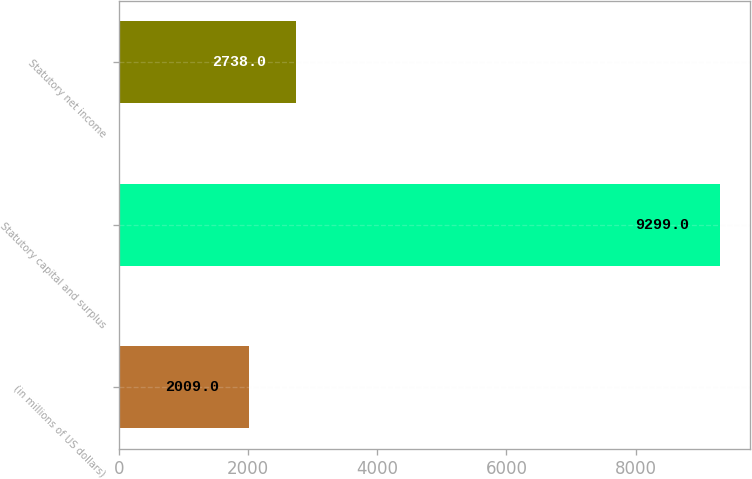<chart> <loc_0><loc_0><loc_500><loc_500><bar_chart><fcel>(in millions of US dollars)<fcel>Statutory capital and surplus<fcel>Statutory net income<nl><fcel>2009<fcel>9299<fcel>2738<nl></chart> 